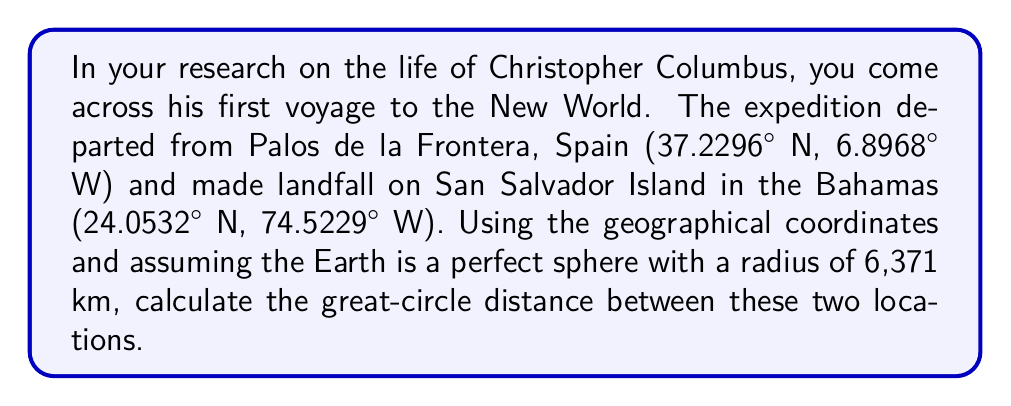Can you answer this question? To calculate the great-circle distance between two points on a sphere, we can use the Haversine formula:

1. Convert the latitude and longitude coordinates from degrees to radians:
   $\phi_1 = 37.2296° \times \frac{\pi}{180} = 0.6499$ rad
   $\lambda_1 = -6.8968° \times \frac{\pi}{180} = -0.1204$ rad
   $\phi_2 = 24.0532° \times \frac{\pi}{180} = 0.4198$ rad
   $\lambda_2 = -74.5229° \times \frac{\pi}{180} = -1.3006$ rad

2. Calculate the difference in longitude:
   $\Delta\lambda = \lambda_2 - \lambda_1 = -1.1802$ rad

3. Apply the Haversine formula:
   $$a = \sin^2\left(\frac{\phi_2 - \phi_1}{2}\right) + \cos(\phi_1)\cos(\phi_2)\sin^2\left(\frac{\Delta\lambda}{2}\right)$$
   $$a = \sin^2\left(\frac{0.4198 - 0.6499}{2}\right) + \cos(0.6499)\cos(0.4198)\sin^2\left(\frac{-1.1802}{2}\right)$$
   $$a = 0.2957$$

4. Calculate the central angle:
   $$c = 2 \times \arctan2(\sqrt{a}, \sqrt{1-a}) = 1.1406$$

5. Compute the great-circle distance:
   $$d = R \times c$$
   where $R$ is the Earth's radius (6,371 km)
   $$d = 6371 \times 1.1406 = 7266.37$$ km

Therefore, the great-circle distance between Palos de la Frontera and San Salvador Island is approximately 7,266.37 km.
Answer: 7,266.37 km 